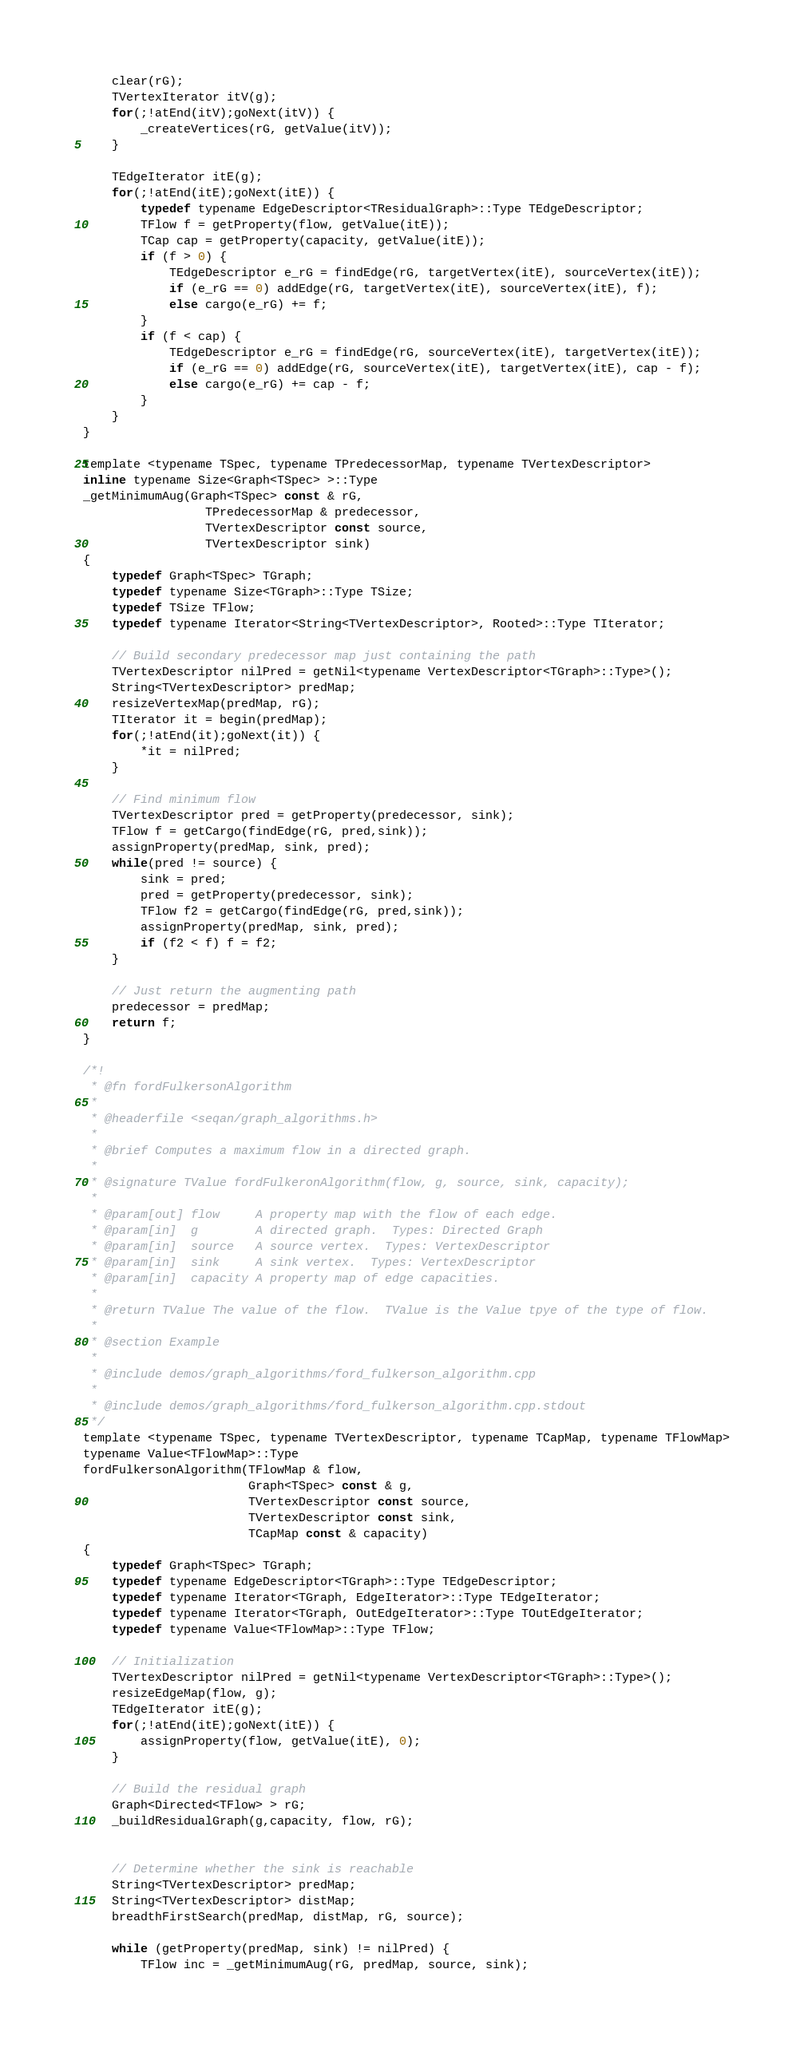Convert code to text. <code><loc_0><loc_0><loc_500><loc_500><_C_>
    clear(rG);
    TVertexIterator itV(g);
    for(;!atEnd(itV);goNext(itV)) {
        _createVertices(rG, getValue(itV));
    }

    TEdgeIterator itE(g);
    for(;!atEnd(itE);goNext(itE)) {
        typedef typename EdgeDescriptor<TResidualGraph>::Type TEdgeDescriptor;
        TFlow f = getProperty(flow, getValue(itE));
        TCap cap = getProperty(capacity, getValue(itE));
        if (f > 0) {
            TEdgeDescriptor e_rG = findEdge(rG, targetVertex(itE), sourceVertex(itE));
            if (e_rG == 0) addEdge(rG, targetVertex(itE), sourceVertex(itE), f);
            else cargo(e_rG) += f;
        }
        if (f < cap) {
            TEdgeDescriptor e_rG = findEdge(rG, sourceVertex(itE), targetVertex(itE));
            if (e_rG == 0) addEdge(rG, sourceVertex(itE), targetVertex(itE), cap - f);
            else cargo(e_rG) += cap - f;
        }
    }
}

template <typename TSpec, typename TPredecessorMap, typename TVertexDescriptor>
inline typename Size<Graph<TSpec> >::Type
_getMinimumAug(Graph<TSpec> const & rG,
                 TPredecessorMap & predecessor,
                 TVertexDescriptor const source,
                 TVertexDescriptor sink)
{
    typedef Graph<TSpec> TGraph;
    typedef typename Size<TGraph>::Type TSize;
    typedef TSize TFlow;
    typedef typename Iterator<String<TVertexDescriptor>, Rooted>::Type TIterator;

    // Build secondary predecessor map just containing the path
    TVertexDescriptor nilPred = getNil<typename VertexDescriptor<TGraph>::Type>();
    String<TVertexDescriptor> predMap;
    resizeVertexMap(predMap, rG);
    TIterator it = begin(predMap);
    for(;!atEnd(it);goNext(it)) {
        *it = nilPred;
    }

    // Find minimum flow
    TVertexDescriptor pred = getProperty(predecessor, sink);
    TFlow f = getCargo(findEdge(rG, pred,sink));
    assignProperty(predMap, sink, pred);
    while(pred != source) {
        sink = pred;
        pred = getProperty(predecessor, sink);
        TFlow f2 = getCargo(findEdge(rG, pred,sink));
        assignProperty(predMap, sink, pred);
        if (f2 < f) f = f2;
    }

    // Just return the augmenting path
    predecessor = predMap;
    return f;
}

/*!
 * @fn fordFulkersonAlgorithm
 *
 * @headerfile <seqan/graph_algorithms.h>
 *
 * @brief Computes a maximum flow in a directed graph.
 *
 * @signature TValue fordFulkeronAlgorithm(flow, g, source, sink, capacity);
 *
 * @param[out] flow     A property map with the flow of each edge.
 * @param[in]  g        A directed graph.  Types: Directed Graph
 * @param[in]  source   A source vertex.  Types: VertexDescriptor
 * @param[in]  sink     A sink vertex.  Types: VertexDescriptor
 * @param[in]  capacity A property map of edge capacities.
 *
 * @return TValue The value of the flow.  TValue is the Value tpye of the type of flow.
 *
 * @section Example
 *
 * @include demos/graph_algorithms/ford_fulkerson_algorithm.cpp
 *
 * @include demos/graph_algorithms/ford_fulkerson_algorithm.cpp.stdout
 */
template <typename TSpec, typename TVertexDescriptor, typename TCapMap, typename TFlowMap>
typename Value<TFlowMap>::Type
fordFulkersonAlgorithm(TFlowMap & flow,
                       Graph<TSpec> const & g,
                       TVertexDescriptor const source,
                       TVertexDescriptor const sink,
                       TCapMap const & capacity)
{
    typedef Graph<TSpec> TGraph;
    typedef typename EdgeDescriptor<TGraph>::Type TEdgeDescriptor;
    typedef typename Iterator<TGraph, EdgeIterator>::Type TEdgeIterator;
    typedef typename Iterator<TGraph, OutEdgeIterator>::Type TOutEdgeIterator;
    typedef typename Value<TFlowMap>::Type TFlow;

    // Initialization
    TVertexDescriptor nilPred = getNil<typename VertexDescriptor<TGraph>::Type>();
    resizeEdgeMap(flow, g);
    TEdgeIterator itE(g);
    for(;!atEnd(itE);goNext(itE)) {
        assignProperty(flow, getValue(itE), 0);
    }

    // Build the residual graph
    Graph<Directed<TFlow> > rG;
    _buildResidualGraph(g,capacity, flow, rG);


    // Determine whether the sink is reachable
    String<TVertexDescriptor> predMap;
    String<TVertexDescriptor> distMap;
    breadthFirstSearch(predMap, distMap, rG, source);

    while (getProperty(predMap, sink) != nilPred) {
        TFlow inc = _getMinimumAug(rG, predMap, source, sink);</code> 